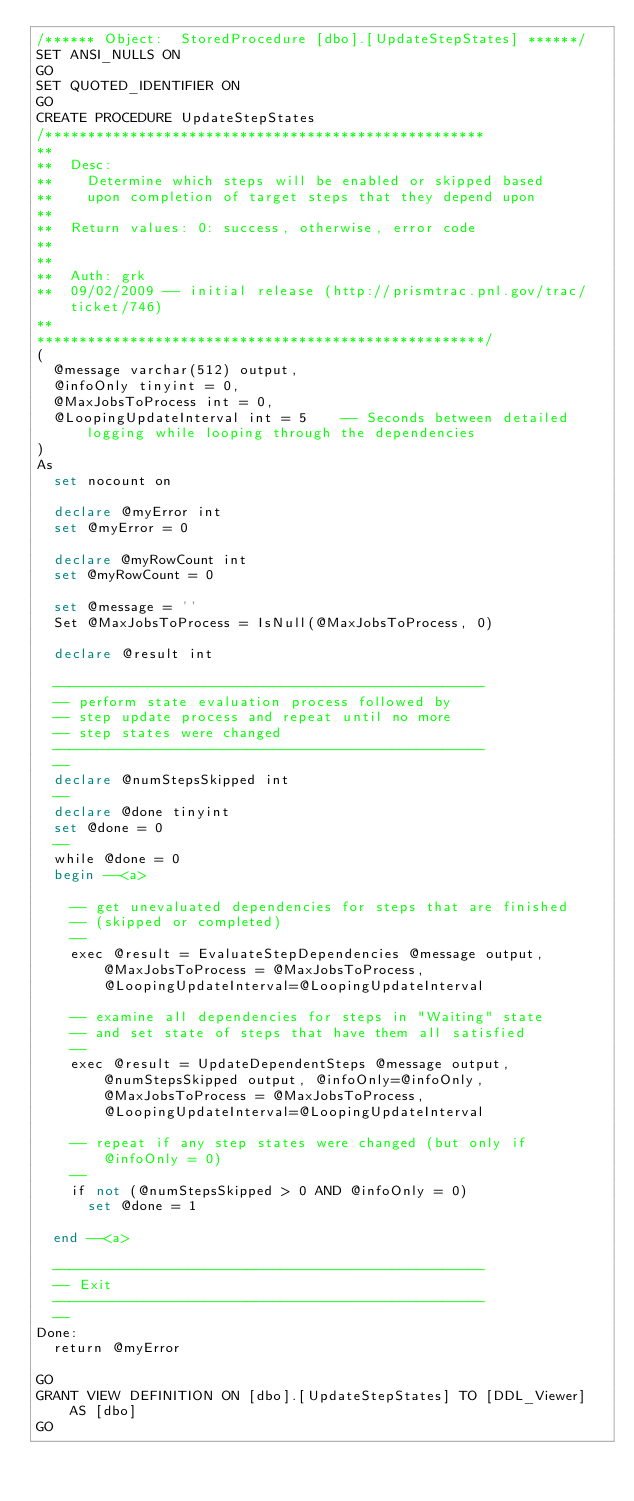<code> <loc_0><loc_0><loc_500><loc_500><_SQL_>/****** Object:  StoredProcedure [dbo].[UpdateStepStates] ******/
SET ANSI_NULLS ON
GO
SET QUOTED_IDENTIFIER ON
GO
CREATE PROCEDURE UpdateStepStates
/****************************************************
**
**	Desc: 
**    Determine which steps will be enabled or skipped based
**    upon completion of target steps that they depend upon
**	
**	Return values: 0: success, otherwise, error code
**
**
**	Auth:	grk
**	09/02/2009 -- initial release (http://prismtrac.pnl.gov/trac/ticket/746)
**    
*****************************************************/
(
	@message varchar(512) output,
	@infoOnly tinyint = 0,
	@MaxJobsToProcess int = 0,
	@LoopingUpdateInterval int = 5		-- Seconds between detailed logging while looping through the dependencies
)
As
	set nocount on
	
	declare @myError int
	set @myError = 0

	declare @myRowCount int
	set @myRowCount = 0
	
	set @message = ''
	Set @MaxJobsToProcess = IsNull(@MaxJobsToProcess, 0)
	
	declare @result int

	---------------------------------------------------
	-- perform state evaluation process followed by 
	-- step update process and repeat until no more
	-- step states were changed
	---------------------------------------------------
	--
	declare @numStepsSkipped int
	--
	declare @done tinyint
	set @done = 0
	--
	while @done = 0
	begin --<a>

		-- get unevaluated dependencies for steps that are finished 
		-- (skipped or completed)
		--
		exec @result = EvaluateStepDependencies @message output, @MaxJobsToProcess = @MaxJobsToProcess, @LoopingUpdateInterval=@LoopingUpdateInterval

		-- examine all dependencies for steps in "Waiting" state
		-- and set state of steps that have them all satisfied
		--
		exec @result = UpdateDependentSteps @message output, @numStepsSkipped output, @infoOnly=@infoOnly, @MaxJobsToProcess = @MaxJobsToProcess, @LoopingUpdateInterval=@LoopingUpdateInterval
		
		-- repeat if any step states were changed (but only if @infoOnly = 0)
		--
		if not (@numStepsSkipped > 0 AND @infoOnly = 0)
			set @done = 1
		
	end --<a>

	---------------------------------------------------
	-- Exit
	---------------------------------------------------
	--
Done:
	return @myError

GO
GRANT VIEW DEFINITION ON [dbo].[UpdateStepStates] TO [DDL_Viewer] AS [dbo]
GO
</code> 